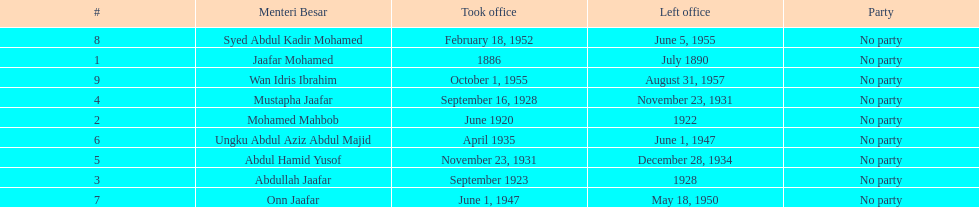Who was in office after mustapha jaafar Abdul Hamid Yusof. 